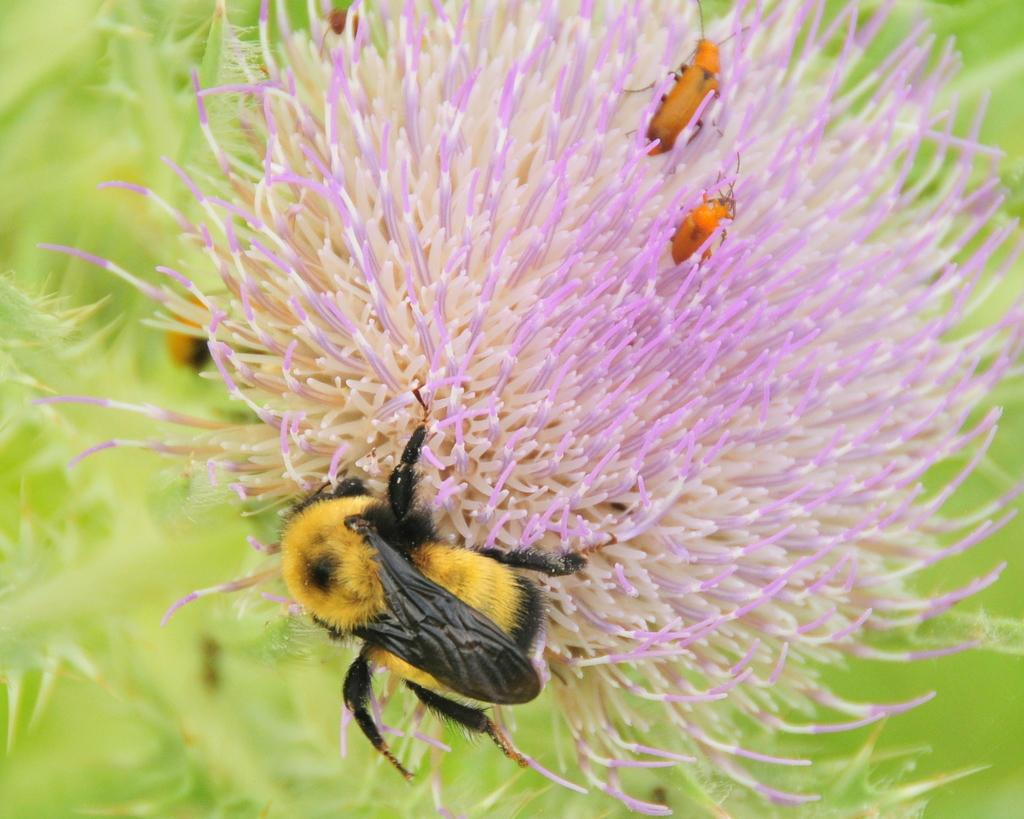What is the main subject of the image? The main subject of the image is a honey bee on a flower. Are there any other insects present in the image? Yes, there are many insects on a flower in the image. What type of vegetation can be seen in the image? Grass is visible in the bottom right of the image. What type of egg is being used by the organization in the image? There is no egg or organization present in the image; it features a honey bee on a flower and other insects on the same flower. 